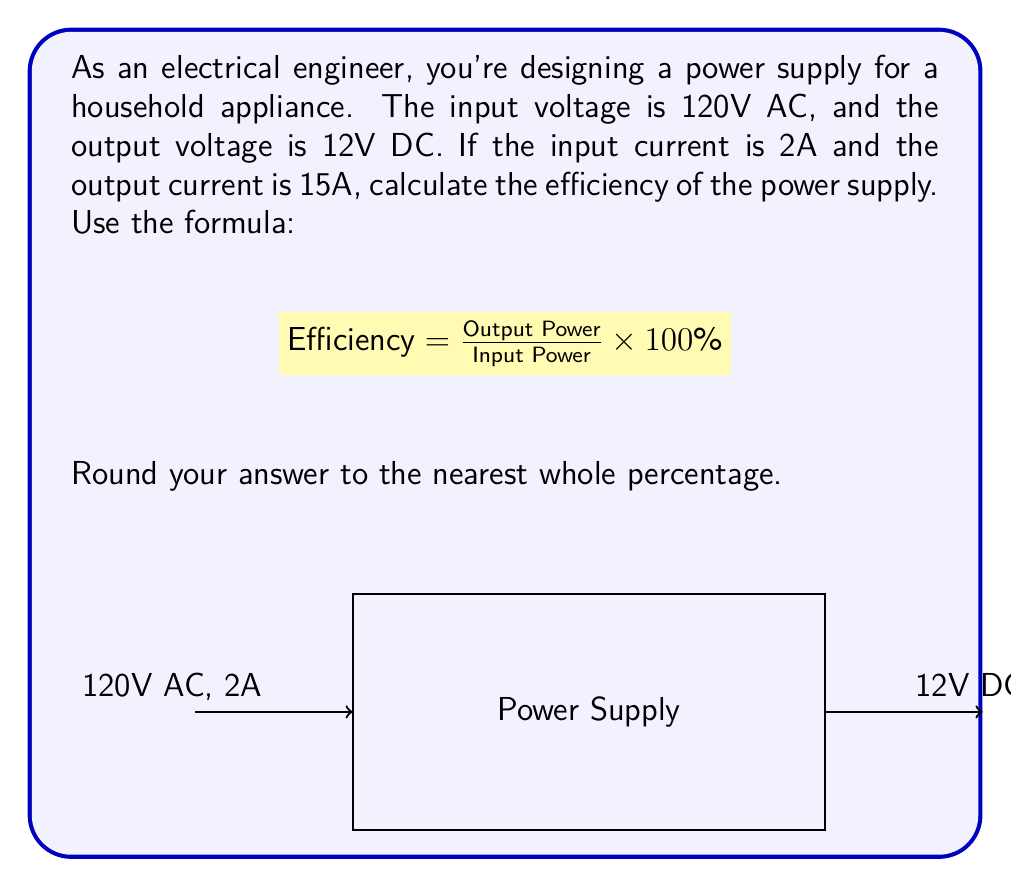Help me with this question. Let's approach this step-by-step:

1) First, we need to calculate the input and output power:

   Input Power = Input Voltage × Input Current
   $P_{in} = 120V \times 2A = 240W$

   Output Power = Output Voltage × Output Current
   $P_{out} = 12V \times 15A = 180W$

2) Now we can use the efficiency formula:

   $\text{Efficiency} = \frac{\text{Output Power}}{\text{Input Power}} \times 100\%$

3) Substituting our values:

   $\text{Efficiency} = \frac{180W}{240W} \times 100\%$

4) Simplifying:

   $\text{Efficiency} = 0.75 \times 100\% = 75\%$

5) Rounding to the nearest whole percentage:

   Efficiency ≈ 75%

Therefore, the efficiency of the power supply is approximately 75%.
Answer: 75% 